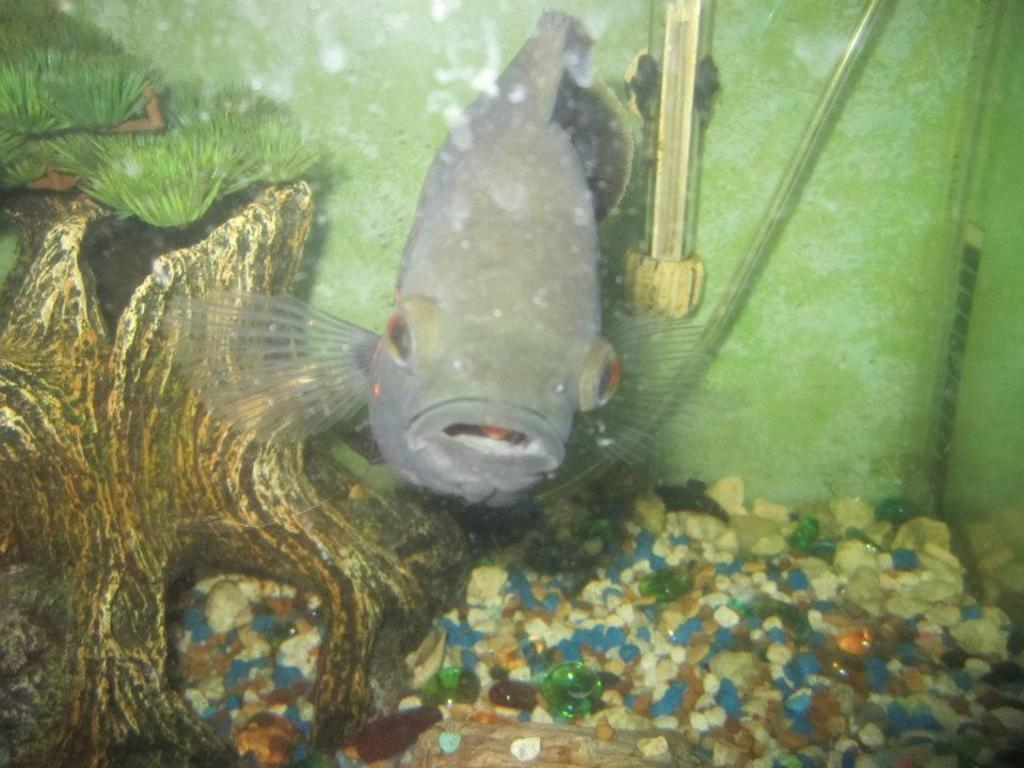What type of animal is in the image? There is a fish in the image. Where is the fish located? The fish is in an aquarium. What can be seen below the fish? There are color stones below the fish. What is on the left side of the image? There is a plant on the left side of the image. What type of bike can be seen in the image? There is no bike present in the image. What color is the flame on the fish's head? Fish do not have flames on their heads, and there is no mention of a flame in the image. 